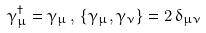<formula> <loc_0><loc_0><loc_500><loc_500>\gamma _ { \mu } ^ { \dagger } = \gamma _ { \mu } \, , \, \{ \gamma _ { \mu } , \gamma _ { \nu } \} = 2 \, \delta _ { \mu \nu }</formula> 